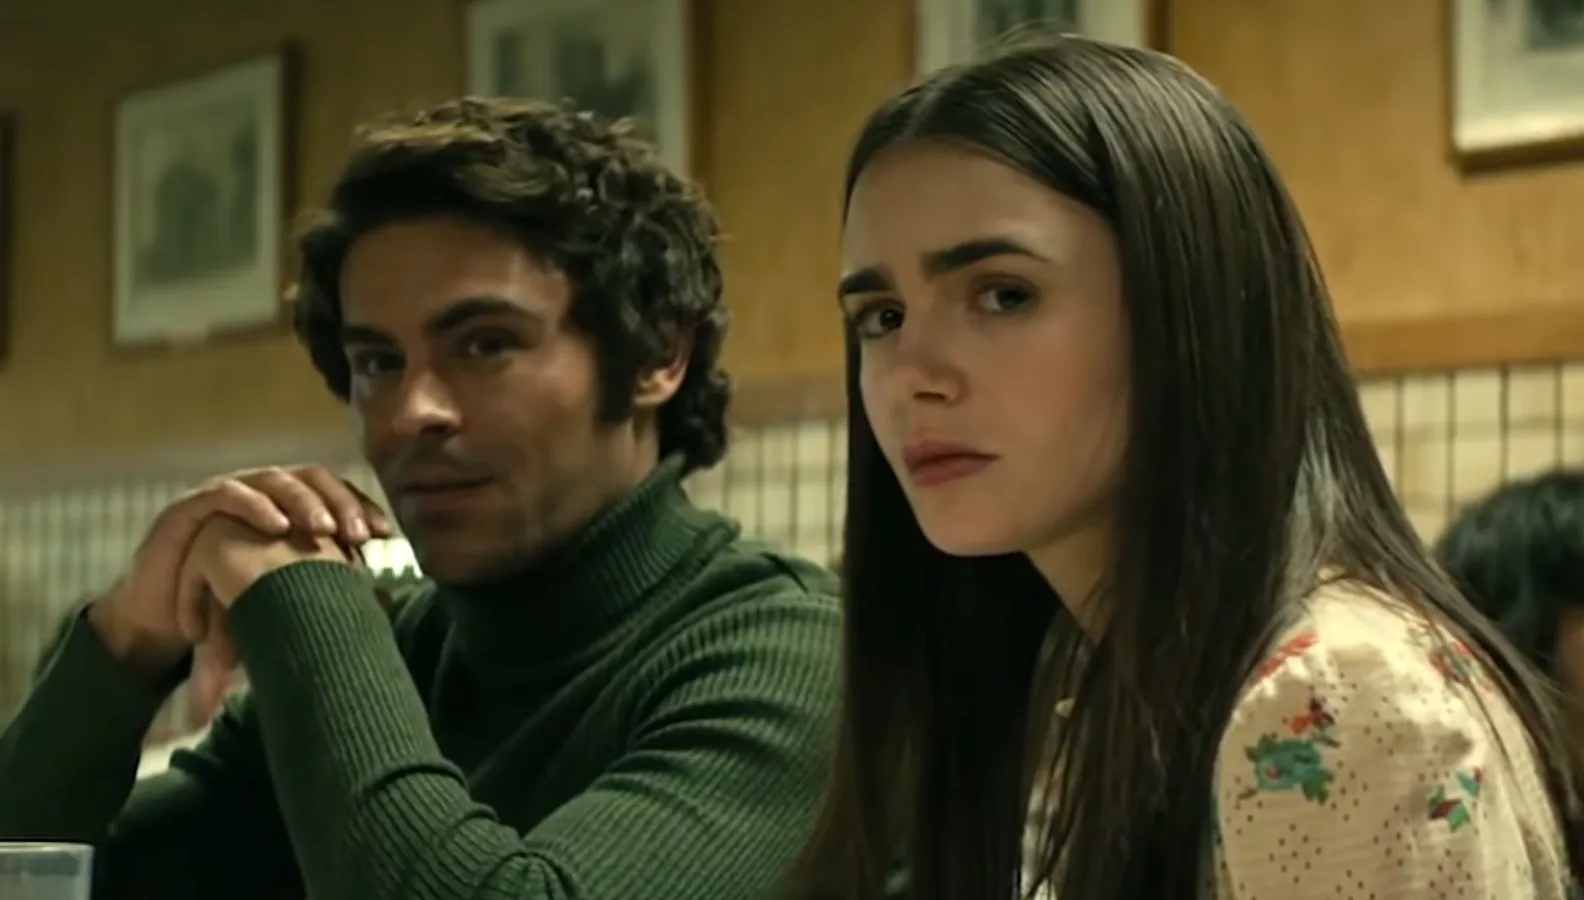Can you infer anything about the characters' relationship or the topic of their conversation based on their body language and expressions? Their body language and expressions reveal a sense of seriousness and connection. The fact that they sit closely in a booth and share this quiet intensity suggests a meaningful bond, possibly of a personal nature. The contemplative expressions might indicate that their conversation spans deep or emotional topics, where both seem equally invested and affected. What elements in the image could indicate the potential genre of the movie or TV show? The somber expressions, personal proximity, and the intimate diner setting could typically be associated with drama genre. The serious nature of their expressions might hint at underlying themes of conflict, romance, or deep character development prevalent in dramatic storytelling. 